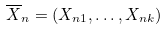Convert formula to latex. <formula><loc_0><loc_0><loc_500><loc_500>\overline { X } _ { n } = ( X _ { n 1 } , \dots , X _ { n k } )</formula> 